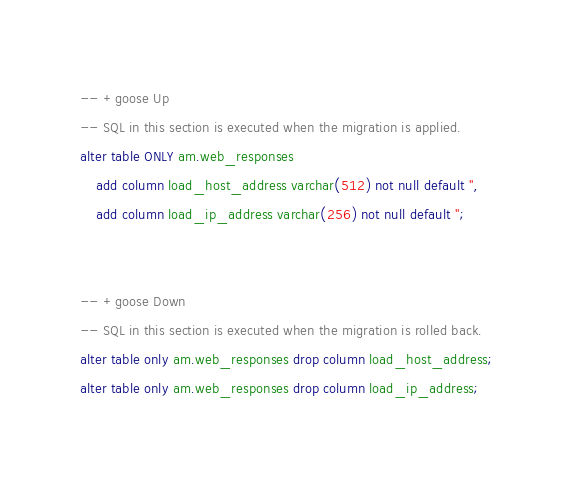<code> <loc_0><loc_0><loc_500><loc_500><_SQL_>-- +goose Up
-- SQL in this section is executed when the migration is applied.
alter table ONLY am.web_responses 
    add column load_host_address varchar(512) not null default '',
    add column load_ip_address varchar(256) not null default '';


-- +goose Down
-- SQL in this section is executed when the migration is rolled back.
alter table only am.web_responses drop column load_host_address;
alter table only am.web_responses drop column load_ip_address;
</code> 